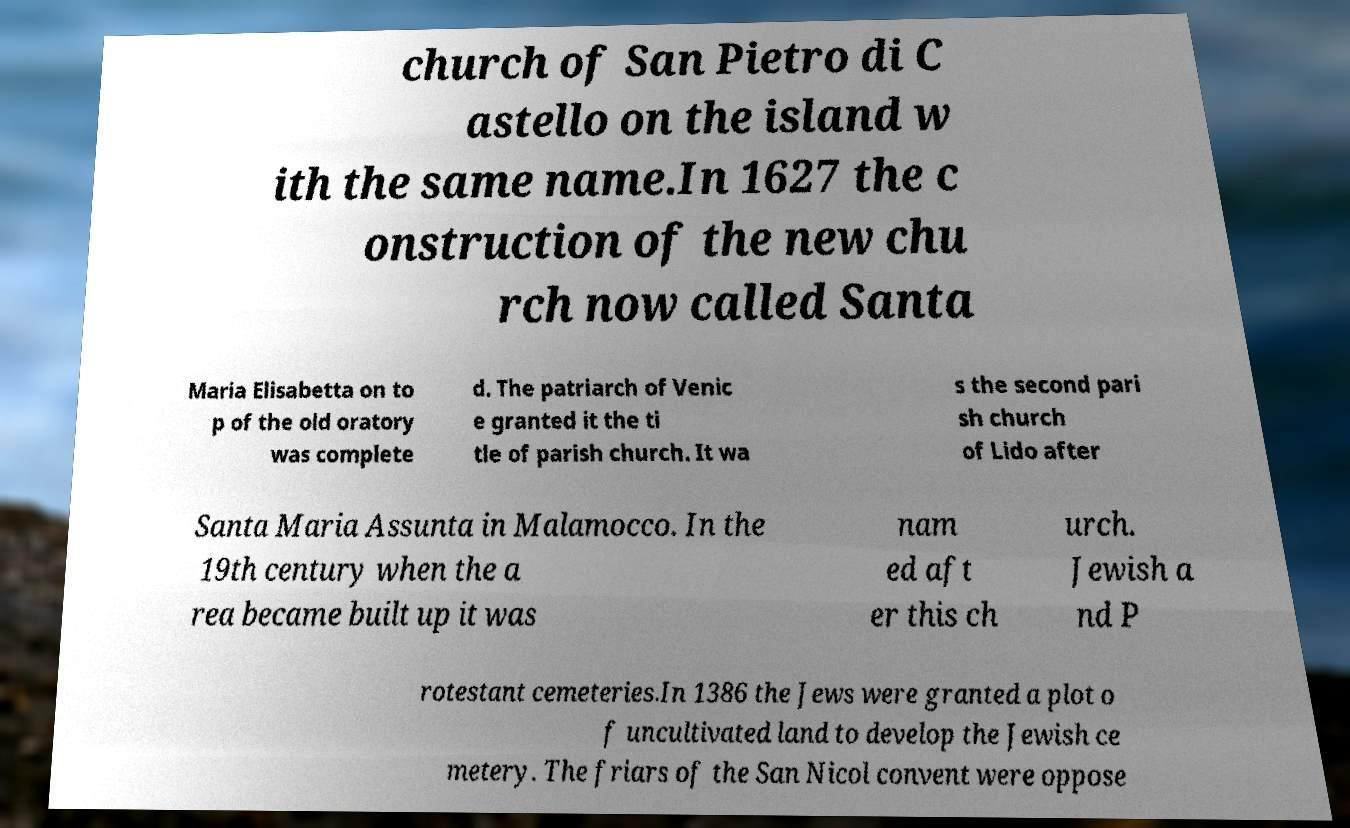I need the written content from this picture converted into text. Can you do that? church of San Pietro di C astello on the island w ith the same name.In 1627 the c onstruction of the new chu rch now called Santa Maria Elisabetta on to p of the old oratory was complete d. The patriarch of Venic e granted it the ti tle of parish church. It wa s the second pari sh church of Lido after Santa Maria Assunta in Malamocco. In the 19th century when the a rea became built up it was nam ed aft er this ch urch. Jewish a nd P rotestant cemeteries.In 1386 the Jews were granted a plot o f uncultivated land to develop the Jewish ce metery. The friars of the San Nicol convent were oppose 